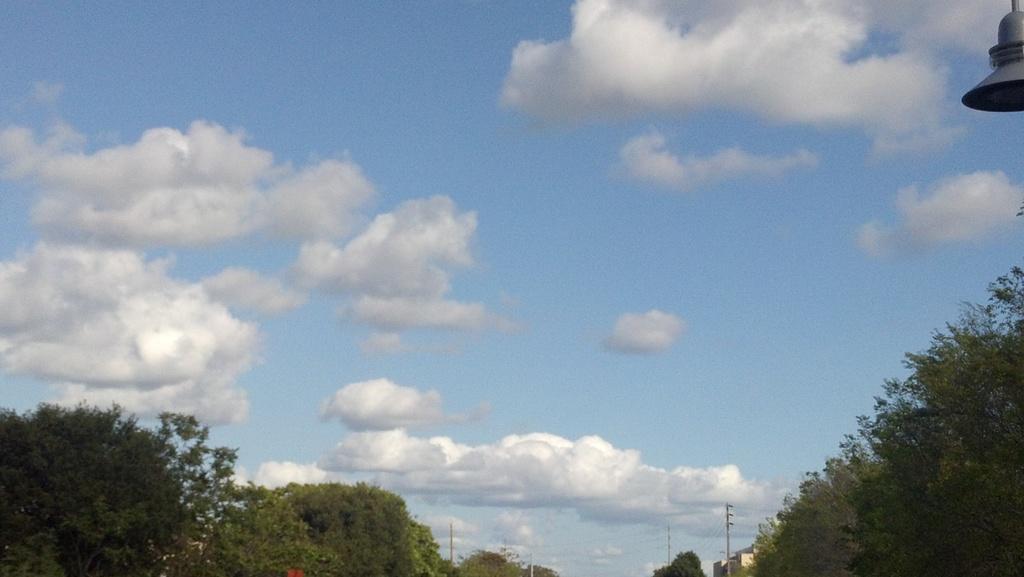Can you describe this image briefly? There are trees and poles at the bottom of this image, and there is a cloudy sky in the background. There is an object in the top right corner of this image. 